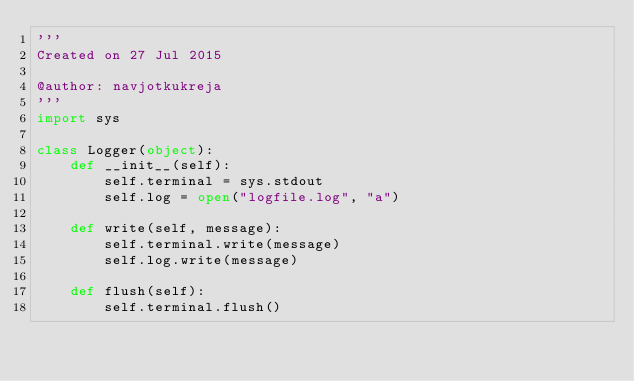Convert code to text. <code><loc_0><loc_0><loc_500><loc_500><_Python_>'''
Created on 27 Jul 2015

@author: navjotkukreja
'''
import sys

class Logger(object):
    def __init__(self):
        self.terminal = sys.stdout
        self.log = open("logfile.log", "a")

    def write(self, message):
        self.terminal.write(message)
        self.log.write(message)  
    
    def flush(self):
        self.terminal.flush()</code> 